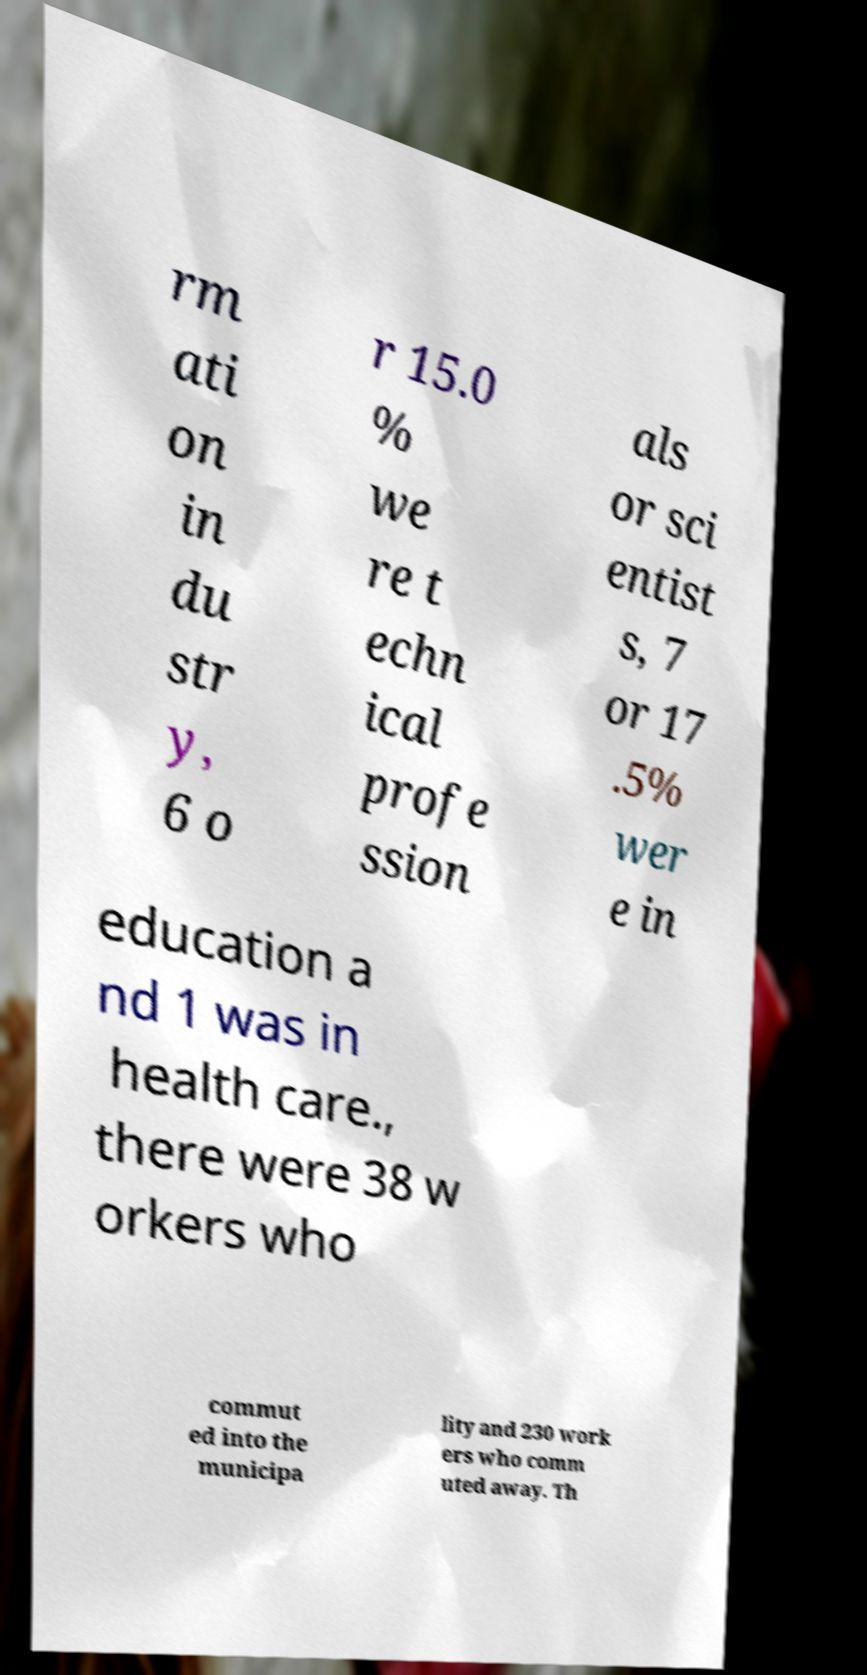Can you accurately transcribe the text from the provided image for me? rm ati on in du str y, 6 o r 15.0 % we re t echn ical profe ssion als or sci entist s, 7 or 17 .5% wer e in education a nd 1 was in health care., there were 38 w orkers who commut ed into the municipa lity and 230 work ers who comm uted away. Th 